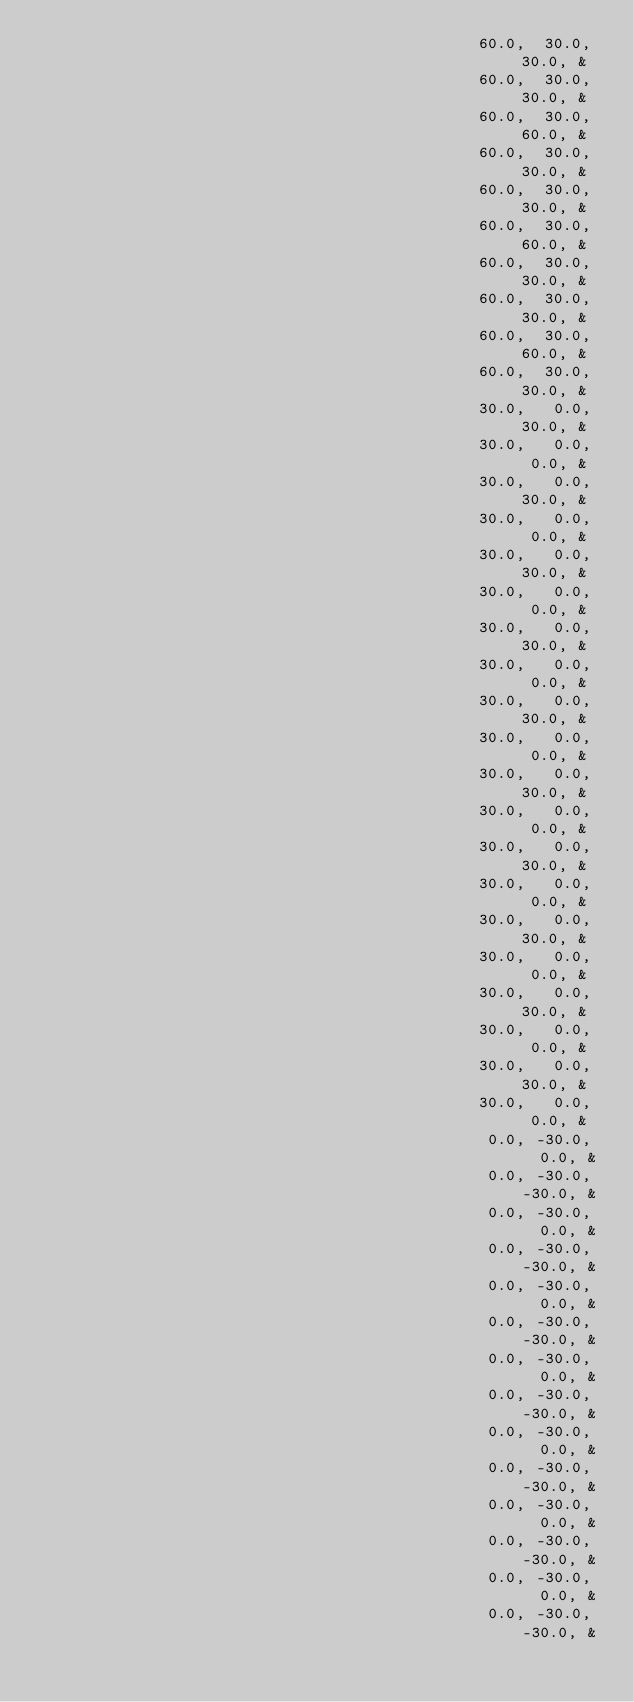<code> <loc_0><loc_0><loc_500><loc_500><_FORTRAN_>                                               60.0,  30.0,  30.0, &
                                               60.0,  30.0,  30.0, &
                                               60.0,  30.0,  60.0, &
                                               60.0,  30.0,  30.0, &
                                               60.0,  30.0,  30.0, &
                                               60.0,  30.0,  60.0, &
                                               60.0,  30.0,  30.0, &
                                               60.0,  30.0,  30.0, &
                                               60.0,  30.0,  60.0, &
                                               60.0,  30.0,  30.0, &
                                               30.0,   0.0,  30.0, &
                                               30.0,   0.0,   0.0, &
                                               30.0,   0.0,  30.0, &
                                               30.0,   0.0,   0.0, &
                                               30.0,   0.0,  30.0, &
                                               30.0,   0.0,   0.0, &
                                               30.0,   0.0,  30.0, &
                                               30.0,   0.0,   0.0, &
                                               30.0,   0.0,  30.0, &
                                               30.0,   0.0,   0.0, &
                                               30.0,   0.0,  30.0, &
                                               30.0,   0.0,   0.0, &
                                               30.0,   0.0,  30.0, &
                                               30.0,   0.0,   0.0, &
                                               30.0,   0.0,  30.0, &
                                               30.0,   0.0,   0.0, &
                                               30.0,   0.0,  30.0, &
                                               30.0,   0.0,   0.0, &
                                               30.0,   0.0,  30.0, &
                                               30.0,   0.0,   0.0, &
                                                0.0, -30.0,   0.0, &
                                                0.0, -30.0, -30.0, &
                                                0.0, -30.0,   0.0, &
                                                0.0, -30.0, -30.0, &
                                                0.0, -30.0,   0.0, &
                                                0.0, -30.0, -30.0, &
                                                0.0, -30.0,   0.0, &
                                                0.0, -30.0, -30.0, &
                                                0.0, -30.0,   0.0, &
                                                0.0, -30.0, -30.0, &
                                                0.0, -30.0,   0.0, &
                                                0.0, -30.0, -30.0, &
                                                0.0, -30.0,   0.0, &
                                                0.0, -30.0, -30.0, &</code> 